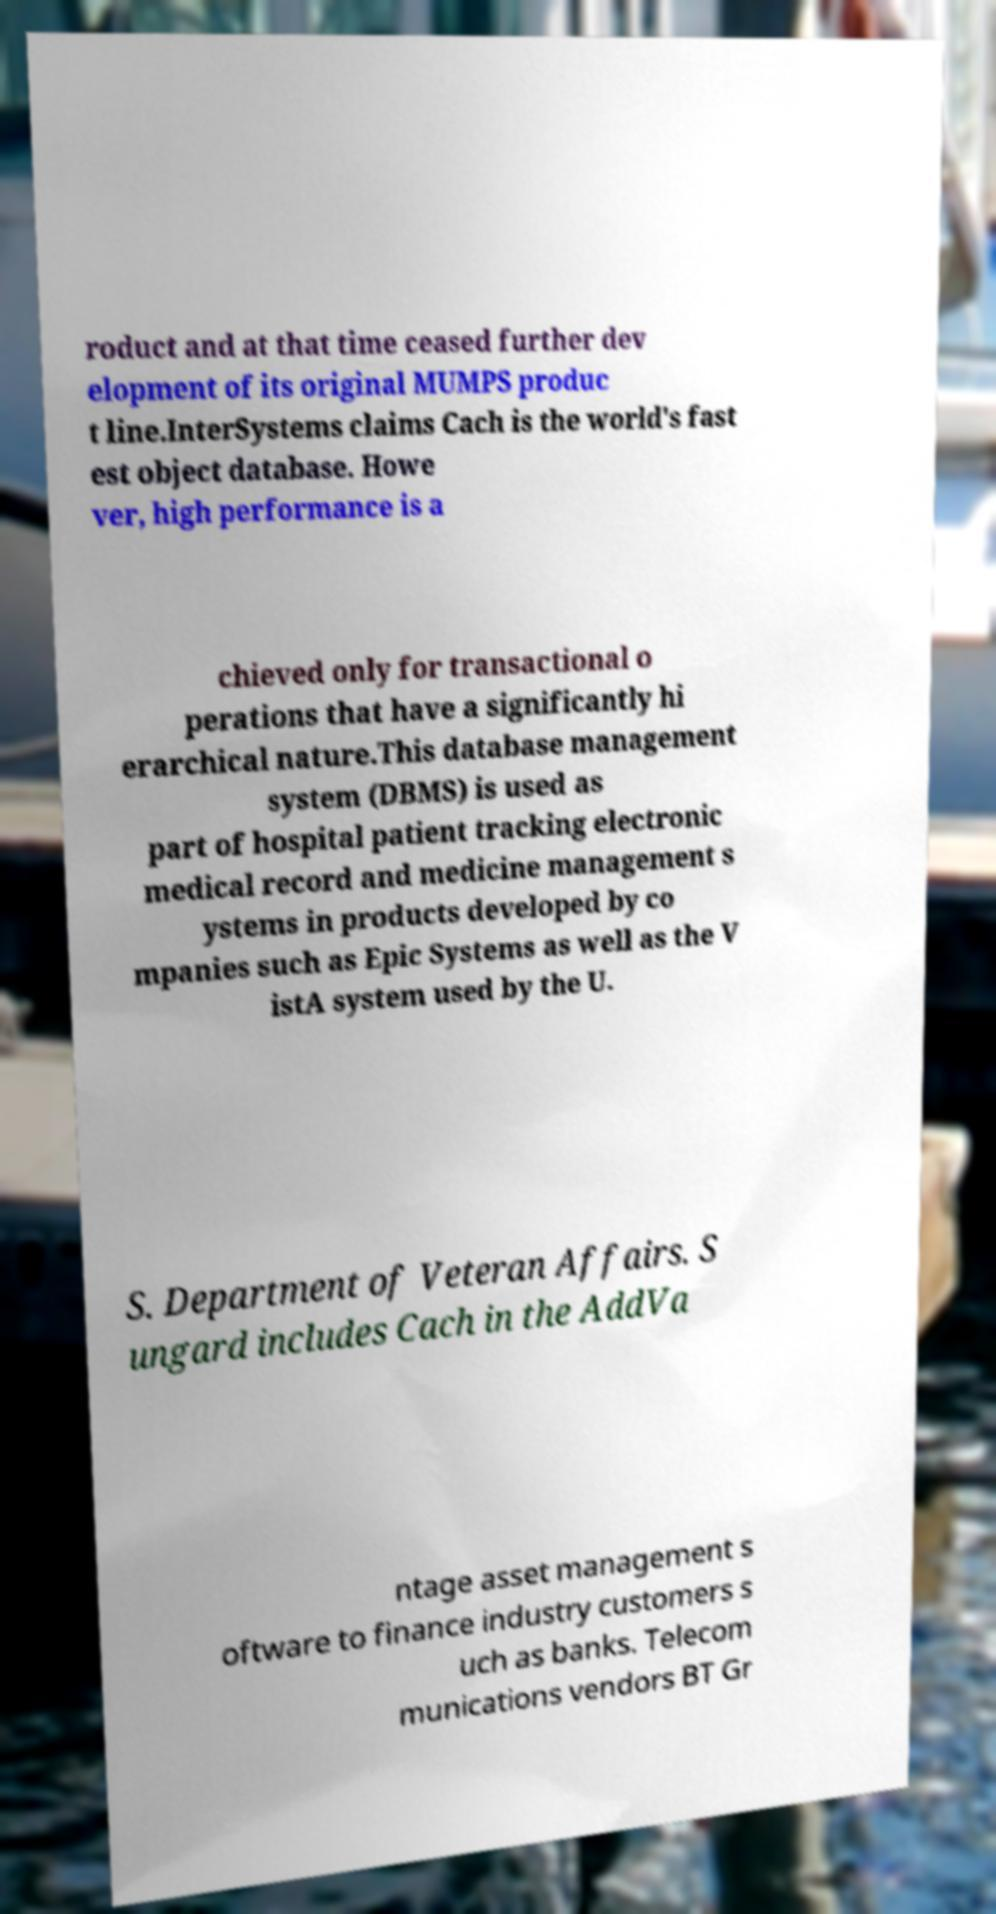I need the written content from this picture converted into text. Can you do that? roduct and at that time ceased further dev elopment of its original MUMPS produc t line.InterSystems claims Cach is the world's fast est object database. Howe ver, high performance is a chieved only for transactional o perations that have a significantly hi erarchical nature.This database management system (DBMS) is used as part of hospital patient tracking electronic medical record and medicine management s ystems in products developed by co mpanies such as Epic Systems as well as the V istA system used by the U. S. Department of Veteran Affairs. S ungard includes Cach in the AddVa ntage asset management s oftware to finance industry customers s uch as banks. Telecom munications vendors BT Gr 